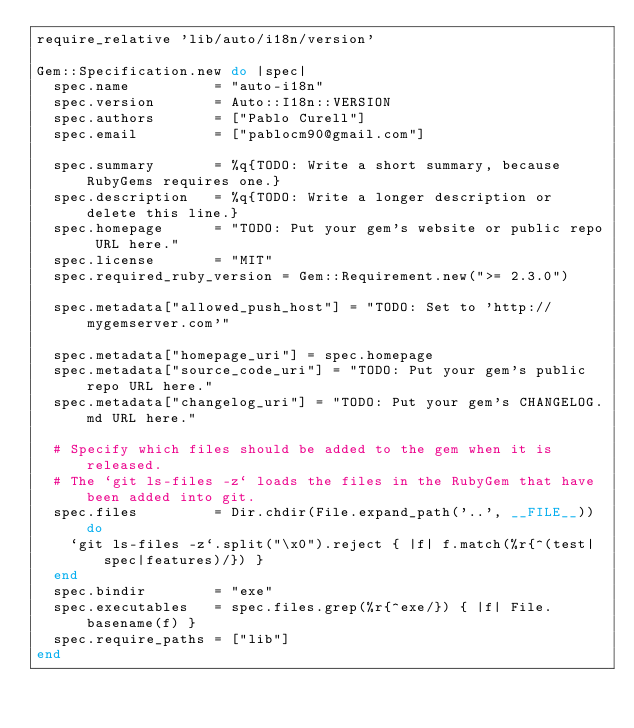<code> <loc_0><loc_0><loc_500><loc_500><_Ruby_>require_relative 'lib/auto/i18n/version'

Gem::Specification.new do |spec|
  spec.name          = "auto-i18n"
  spec.version       = Auto::I18n::VERSION
  spec.authors       = ["Pablo Curell"]
  spec.email         = ["pablocm90@gmail.com"]

  spec.summary       = %q{TODO: Write a short summary, because RubyGems requires one.}
  spec.description   = %q{TODO: Write a longer description or delete this line.}
  spec.homepage      = "TODO: Put your gem's website or public repo URL here."
  spec.license       = "MIT"
  spec.required_ruby_version = Gem::Requirement.new(">= 2.3.0")

  spec.metadata["allowed_push_host"] = "TODO: Set to 'http://mygemserver.com'"

  spec.metadata["homepage_uri"] = spec.homepage
  spec.metadata["source_code_uri"] = "TODO: Put your gem's public repo URL here."
  spec.metadata["changelog_uri"] = "TODO: Put your gem's CHANGELOG.md URL here."

  # Specify which files should be added to the gem when it is released.
  # The `git ls-files -z` loads the files in the RubyGem that have been added into git.
  spec.files         = Dir.chdir(File.expand_path('..', __FILE__)) do
    `git ls-files -z`.split("\x0").reject { |f| f.match(%r{^(test|spec|features)/}) }
  end
  spec.bindir        = "exe"
  spec.executables   = spec.files.grep(%r{^exe/}) { |f| File.basename(f) }
  spec.require_paths = ["lib"]
end
</code> 